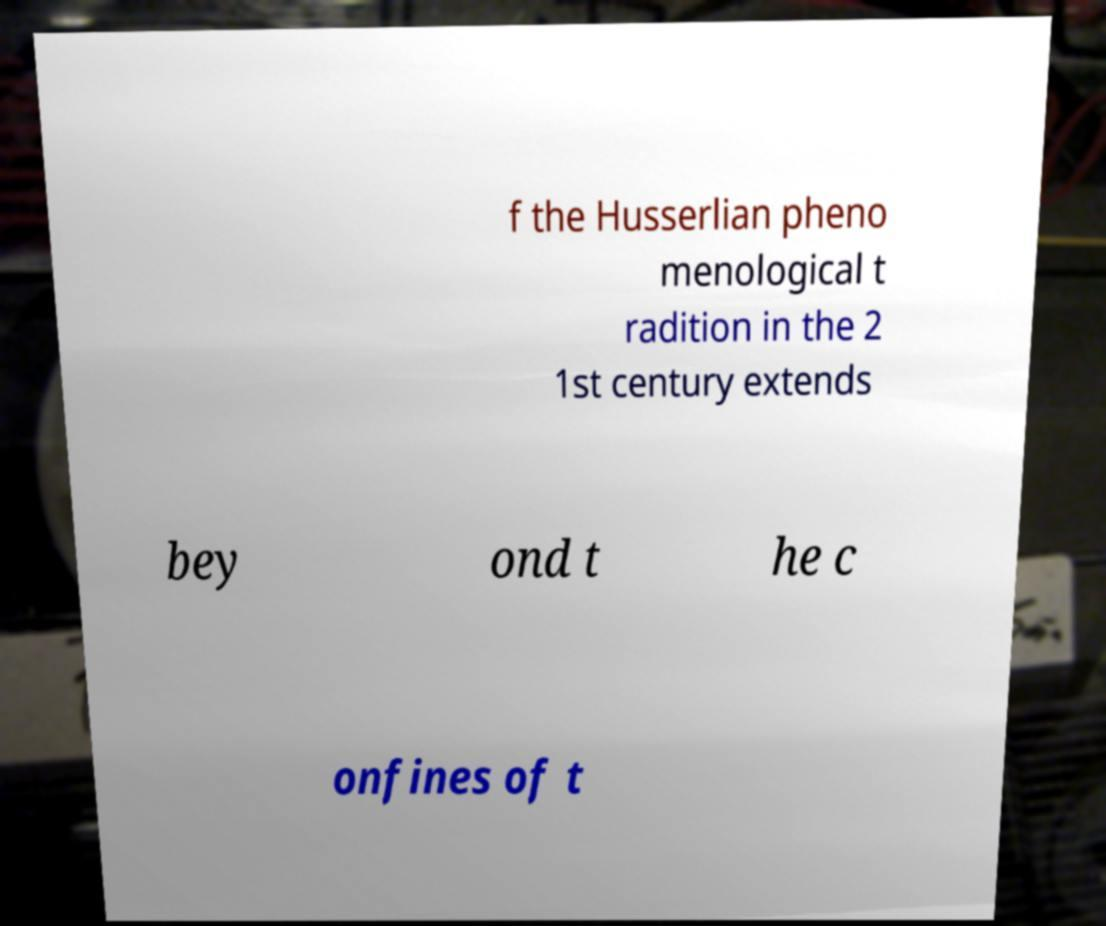Could you extract and type out the text from this image? f the Husserlian pheno menological t radition in the 2 1st century extends bey ond t he c onfines of t 